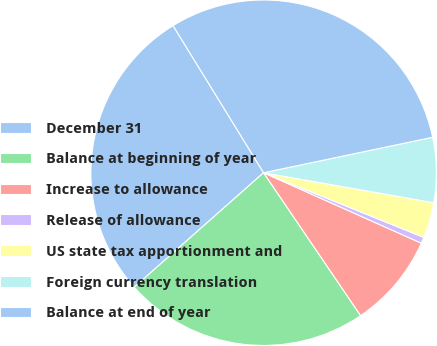<chart> <loc_0><loc_0><loc_500><loc_500><pie_chart><fcel>December 31<fcel>Balance at beginning of year<fcel>Increase to allowance<fcel>Release of allowance<fcel>US state tax apportionment and<fcel>Foreign currency translation<fcel>Balance at end of year<nl><fcel>27.75%<fcel>22.97%<fcel>8.82%<fcel>0.58%<fcel>3.33%<fcel>6.07%<fcel>30.49%<nl></chart> 